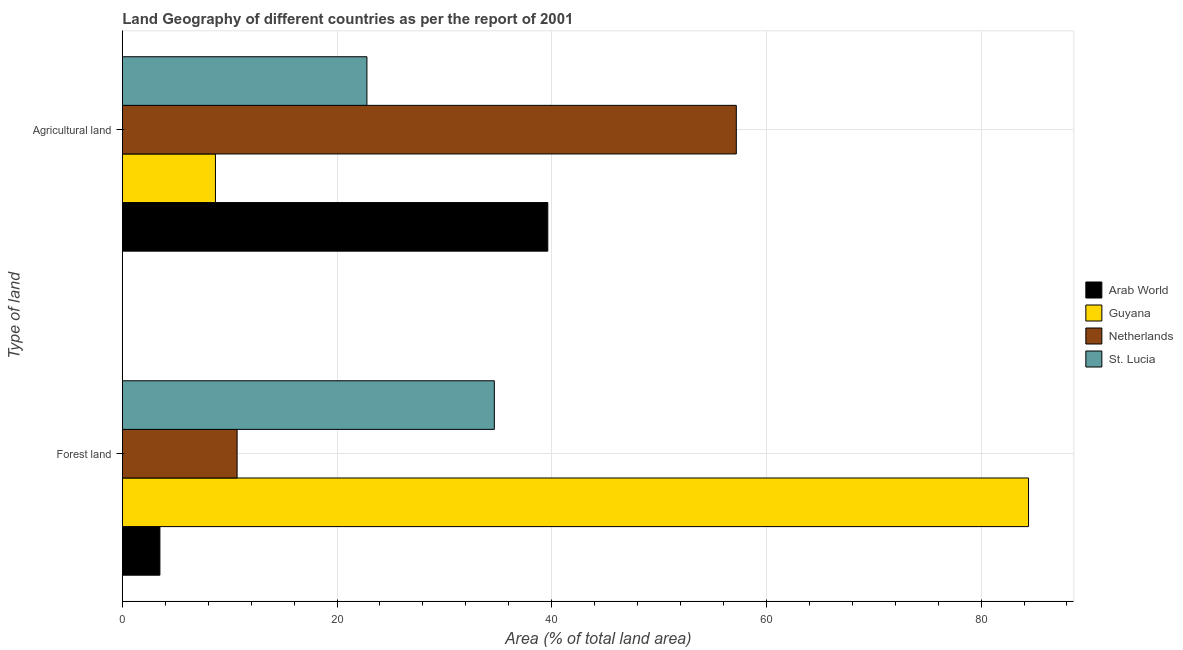How many different coloured bars are there?
Ensure brevity in your answer.  4. How many groups of bars are there?
Make the answer very short. 2. Are the number of bars per tick equal to the number of legend labels?
Provide a succinct answer. Yes. How many bars are there on the 2nd tick from the top?
Provide a succinct answer. 4. What is the label of the 2nd group of bars from the top?
Your answer should be compact. Forest land. What is the percentage of land area under forests in Guyana?
Give a very brief answer. 84.42. Across all countries, what is the maximum percentage of land area under agriculture?
Your response must be concise. 57.2. Across all countries, what is the minimum percentage of land area under agriculture?
Provide a short and direct response. 8.68. In which country was the percentage of land area under agriculture maximum?
Ensure brevity in your answer.  Netherlands. In which country was the percentage of land area under forests minimum?
Your answer should be compact. Arab World. What is the total percentage of land area under agriculture in the graph?
Your response must be concise. 128.3. What is the difference between the percentage of land area under agriculture in St. Lucia and that in Arab World?
Your response must be concise. -16.85. What is the difference between the percentage of land area under agriculture in St. Lucia and the percentage of land area under forests in Arab World?
Provide a short and direct response. 19.28. What is the average percentage of land area under forests per country?
Ensure brevity in your answer.  33.32. What is the difference between the percentage of land area under forests and percentage of land area under agriculture in Guyana?
Your answer should be compact. 75.74. In how many countries, is the percentage of land area under forests greater than 8 %?
Provide a succinct answer. 3. What is the ratio of the percentage of land area under agriculture in Guyana to that in Arab World?
Keep it short and to the point. 0.22. In how many countries, is the percentage of land area under agriculture greater than the average percentage of land area under agriculture taken over all countries?
Your response must be concise. 2. What does the 3rd bar from the top in Agricultural land represents?
Provide a succinct answer. Guyana. How many countries are there in the graph?
Provide a short and direct response. 4. Are the values on the major ticks of X-axis written in scientific E-notation?
Make the answer very short. No. Does the graph contain any zero values?
Your answer should be compact. No. Where does the legend appear in the graph?
Offer a terse response. Center right. How many legend labels are there?
Keep it short and to the point. 4. What is the title of the graph?
Ensure brevity in your answer.  Land Geography of different countries as per the report of 2001. What is the label or title of the X-axis?
Your answer should be compact. Area (% of total land area). What is the label or title of the Y-axis?
Provide a short and direct response. Type of land. What is the Area (% of total land area) in Arab World in Forest land?
Ensure brevity in your answer.  3.5. What is the Area (% of total land area) in Guyana in Forest land?
Offer a terse response. 84.42. What is the Area (% of total land area) in Netherlands in Forest land?
Keep it short and to the point. 10.69. What is the Area (% of total land area) in St. Lucia in Forest land?
Your answer should be very brief. 34.66. What is the Area (% of total land area) of Arab World in Agricultural land?
Give a very brief answer. 39.64. What is the Area (% of total land area) of Guyana in Agricultural land?
Offer a terse response. 8.68. What is the Area (% of total land area) in Netherlands in Agricultural land?
Provide a succinct answer. 57.2. What is the Area (% of total land area) in St. Lucia in Agricultural land?
Your answer should be very brief. 22.79. Across all Type of land, what is the maximum Area (% of total land area) of Arab World?
Provide a short and direct response. 39.64. Across all Type of land, what is the maximum Area (% of total land area) in Guyana?
Ensure brevity in your answer.  84.42. Across all Type of land, what is the maximum Area (% of total land area) of Netherlands?
Give a very brief answer. 57.2. Across all Type of land, what is the maximum Area (% of total land area) in St. Lucia?
Your answer should be very brief. 34.66. Across all Type of land, what is the minimum Area (% of total land area) of Arab World?
Provide a short and direct response. 3.5. Across all Type of land, what is the minimum Area (% of total land area) of Guyana?
Give a very brief answer. 8.68. Across all Type of land, what is the minimum Area (% of total land area) of Netherlands?
Provide a short and direct response. 10.69. Across all Type of land, what is the minimum Area (% of total land area) of St. Lucia?
Your answer should be compact. 22.79. What is the total Area (% of total land area) of Arab World in the graph?
Provide a short and direct response. 43.14. What is the total Area (% of total land area) of Guyana in the graph?
Provide a short and direct response. 93.1. What is the total Area (% of total land area) in Netherlands in the graph?
Provide a short and direct response. 67.89. What is the total Area (% of total land area) of St. Lucia in the graph?
Ensure brevity in your answer.  57.44. What is the difference between the Area (% of total land area) of Arab World in Forest land and that in Agricultural land?
Offer a terse response. -36.13. What is the difference between the Area (% of total land area) of Guyana in Forest land and that in Agricultural land?
Offer a terse response. 75.74. What is the difference between the Area (% of total land area) of Netherlands in Forest land and that in Agricultural land?
Your answer should be compact. -46.5. What is the difference between the Area (% of total land area) in St. Lucia in Forest land and that in Agricultural land?
Your response must be concise. 11.87. What is the difference between the Area (% of total land area) of Arab World in Forest land and the Area (% of total land area) of Guyana in Agricultural land?
Your answer should be compact. -5.17. What is the difference between the Area (% of total land area) of Arab World in Forest land and the Area (% of total land area) of Netherlands in Agricultural land?
Keep it short and to the point. -53.7. What is the difference between the Area (% of total land area) of Arab World in Forest land and the Area (% of total land area) of St. Lucia in Agricultural land?
Provide a succinct answer. -19.28. What is the difference between the Area (% of total land area) of Guyana in Forest land and the Area (% of total land area) of Netherlands in Agricultural land?
Ensure brevity in your answer.  27.22. What is the difference between the Area (% of total land area) in Guyana in Forest land and the Area (% of total land area) in St. Lucia in Agricultural land?
Provide a short and direct response. 61.63. What is the difference between the Area (% of total land area) of Netherlands in Forest land and the Area (% of total land area) of St. Lucia in Agricultural land?
Offer a very short reply. -12.09. What is the average Area (% of total land area) of Arab World per Type of land?
Provide a short and direct response. 21.57. What is the average Area (% of total land area) of Guyana per Type of land?
Ensure brevity in your answer.  46.55. What is the average Area (% of total land area) of Netherlands per Type of land?
Keep it short and to the point. 33.95. What is the average Area (% of total land area) of St. Lucia per Type of land?
Give a very brief answer. 28.72. What is the difference between the Area (% of total land area) in Arab World and Area (% of total land area) in Guyana in Forest land?
Offer a very short reply. -80.92. What is the difference between the Area (% of total land area) of Arab World and Area (% of total land area) of Netherlands in Forest land?
Your response must be concise. -7.19. What is the difference between the Area (% of total land area) of Arab World and Area (% of total land area) of St. Lucia in Forest land?
Your response must be concise. -31.15. What is the difference between the Area (% of total land area) in Guyana and Area (% of total land area) in Netherlands in Forest land?
Provide a short and direct response. 73.73. What is the difference between the Area (% of total land area) of Guyana and Area (% of total land area) of St. Lucia in Forest land?
Make the answer very short. 49.76. What is the difference between the Area (% of total land area) of Netherlands and Area (% of total land area) of St. Lucia in Forest land?
Offer a terse response. -23.96. What is the difference between the Area (% of total land area) of Arab World and Area (% of total land area) of Guyana in Agricultural land?
Give a very brief answer. 30.96. What is the difference between the Area (% of total land area) of Arab World and Area (% of total land area) of Netherlands in Agricultural land?
Give a very brief answer. -17.56. What is the difference between the Area (% of total land area) of Arab World and Area (% of total land area) of St. Lucia in Agricultural land?
Ensure brevity in your answer.  16.85. What is the difference between the Area (% of total land area) in Guyana and Area (% of total land area) in Netherlands in Agricultural land?
Offer a terse response. -48.52. What is the difference between the Area (% of total land area) of Guyana and Area (% of total land area) of St. Lucia in Agricultural land?
Offer a terse response. -14.11. What is the difference between the Area (% of total land area) of Netherlands and Area (% of total land area) of St. Lucia in Agricultural land?
Provide a succinct answer. 34.41. What is the ratio of the Area (% of total land area) of Arab World in Forest land to that in Agricultural land?
Offer a very short reply. 0.09. What is the ratio of the Area (% of total land area) in Guyana in Forest land to that in Agricultural land?
Make the answer very short. 9.73. What is the ratio of the Area (% of total land area) in Netherlands in Forest land to that in Agricultural land?
Give a very brief answer. 0.19. What is the ratio of the Area (% of total land area) in St. Lucia in Forest land to that in Agricultural land?
Give a very brief answer. 1.52. What is the difference between the highest and the second highest Area (% of total land area) of Arab World?
Provide a succinct answer. 36.13. What is the difference between the highest and the second highest Area (% of total land area) in Guyana?
Offer a very short reply. 75.74. What is the difference between the highest and the second highest Area (% of total land area) of Netherlands?
Your answer should be very brief. 46.5. What is the difference between the highest and the second highest Area (% of total land area) in St. Lucia?
Ensure brevity in your answer.  11.87. What is the difference between the highest and the lowest Area (% of total land area) in Arab World?
Your answer should be very brief. 36.13. What is the difference between the highest and the lowest Area (% of total land area) of Guyana?
Your answer should be very brief. 75.74. What is the difference between the highest and the lowest Area (% of total land area) in Netherlands?
Offer a very short reply. 46.5. What is the difference between the highest and the lowest Area (% of total land area) in St. Lucia?
Provide a succinct answer. 11.87. 